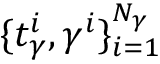Convert formula to latex. <formula><loc_0><loc_0><loc_500><loc_500>\{ t _ { \gamma } ^ { i } , { \gamma } ^ { i } \} _ { i = 1 } ^ { N _ { \gamma } }</formula> 